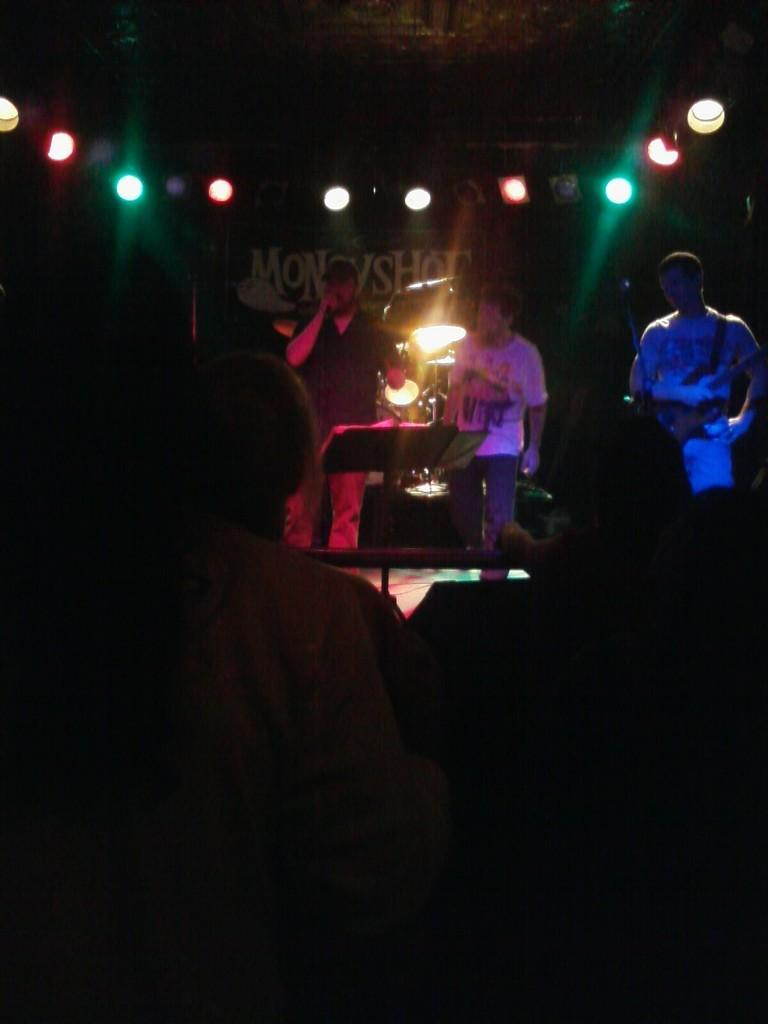Who or what is in front of the image? There are people standing in front of the image. Can you describe the lighting conditions in the image? The scene appears to be dark. What can be seen in the background of the image? There are lights visible in the background. How many men are standing in the image? There are three men standing in the image. What other objects or elements are present in the image? The specific nature of the additional objects or elements is not clearly described. What type of note is being passed between the men in the image? There is no mention of a note being passed between the men in the image. Can you tell me what kind of zipper is on the men's clothing in the image? There is no information about the men's clothing or the presence of a zipper in the image. 